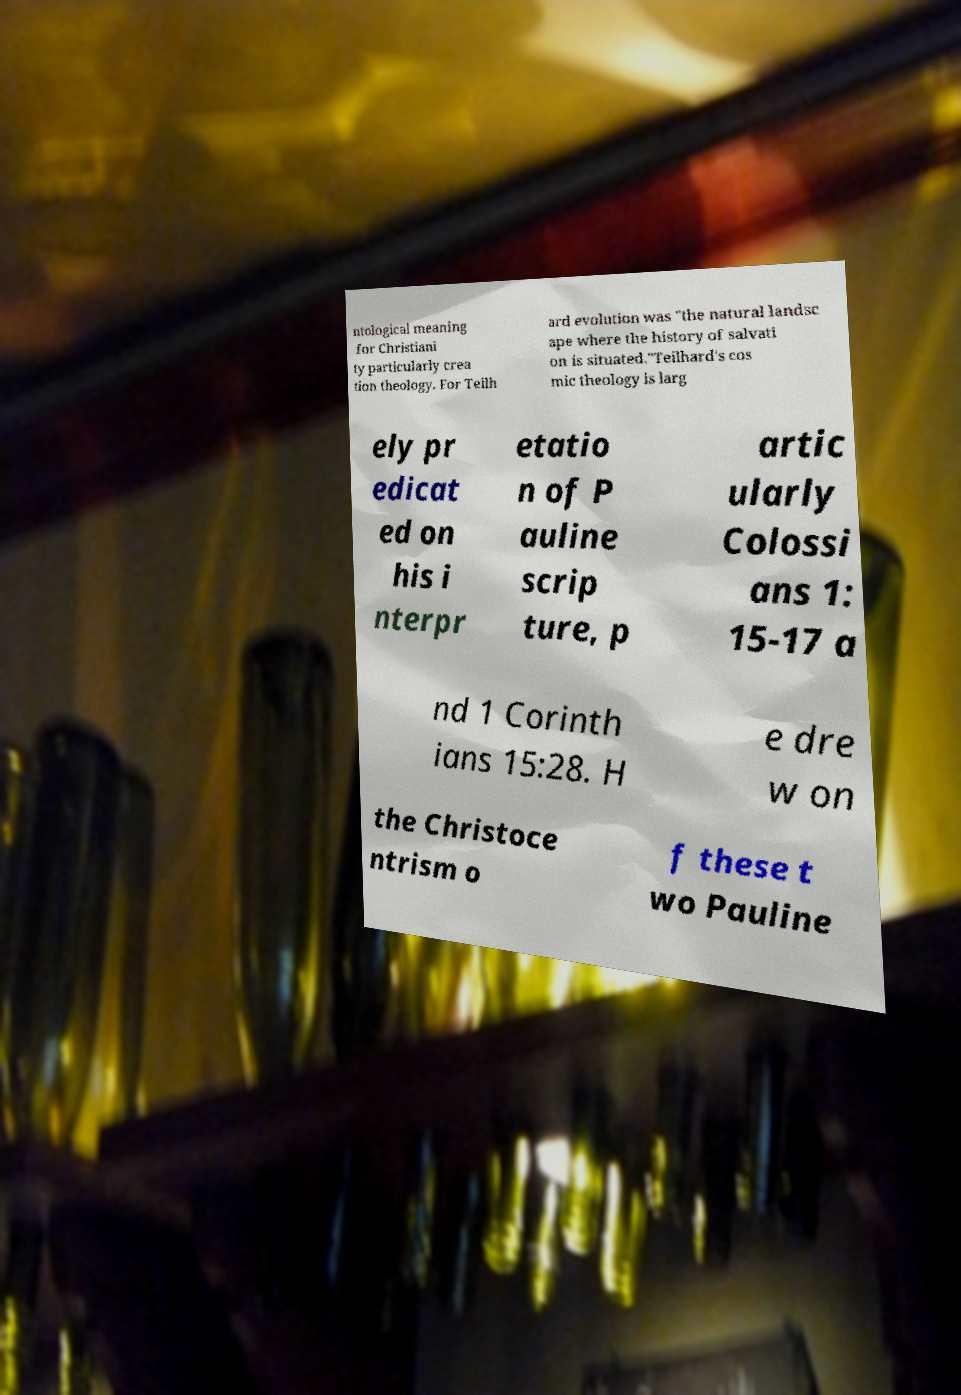Could you extract and type out the text from this image? ntological meaning for Christiani ty particularly crea tion theology. For Teilh ard evolution was "the natural landsc ape where the history of salvati on is situated."Teilhard's cos mic theology is larg ely pr edicat ed on his i nterpr etatio n of P auline scrip ture, p artic ularly Colossi ans 1: 15-17 a nd 1 Corinth ians 15:28. H e dre w on the Christoce ntrism o f these t wo Pauline 